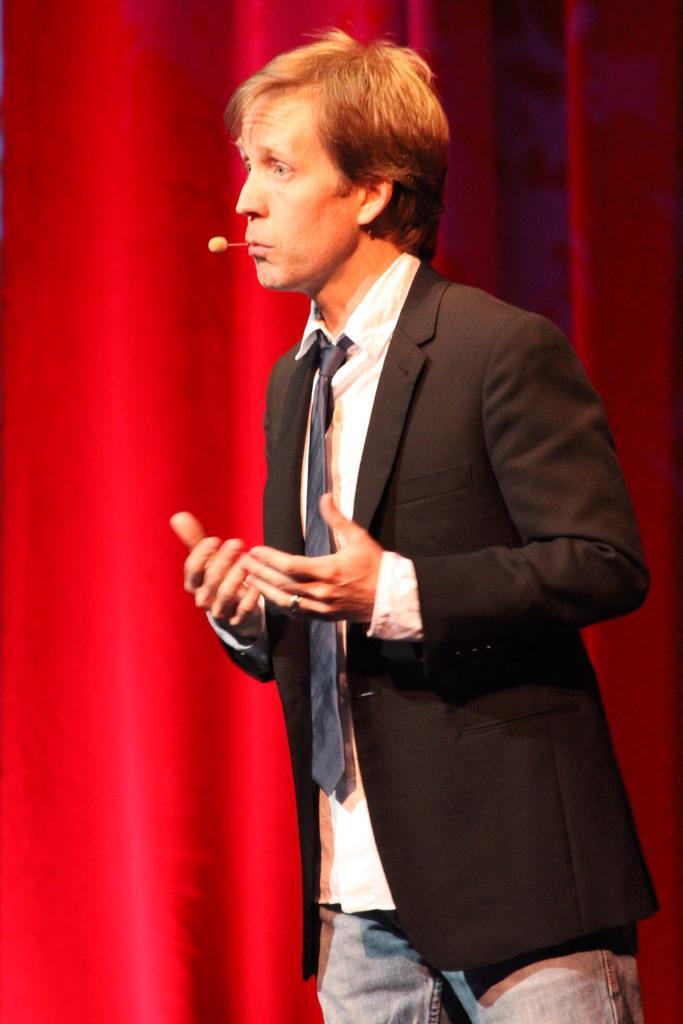Please provide a concise description of this image. In this image there is a man standing and talking, there is a mini microphone, at the background of the image there is a red curtain. 